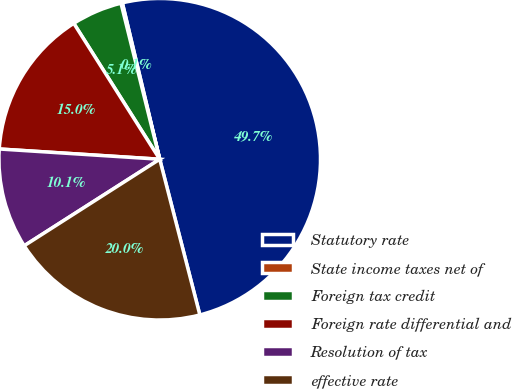Convert chart to OTSL. <chart><loc_0><loc_0><loc_500><loc_500><pie_chart><fcel>Statutory rate<fcel>State income taxes net of<fcel>Foreign tax credit<fcel>Foreign rate differential and<fcel>Resolution of tax<fcel>effective rate<nl><fcel>49.72%<fcel>0.14%<fcel>5.1%<fcel>15.01%<fcel>10.06%<fcel>19.97%<nl></chart> 